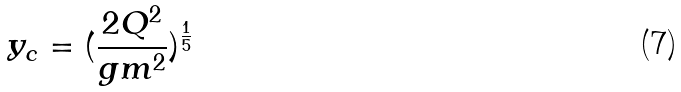<formula> <loc_0><loc_0><loc_500><loc_500>y _ { c } = ( \frac { 2 Q ^ { 2 } } { g m ^ { 2 } } ) ^ { \frac { 1 } { 5 } }</formula> 